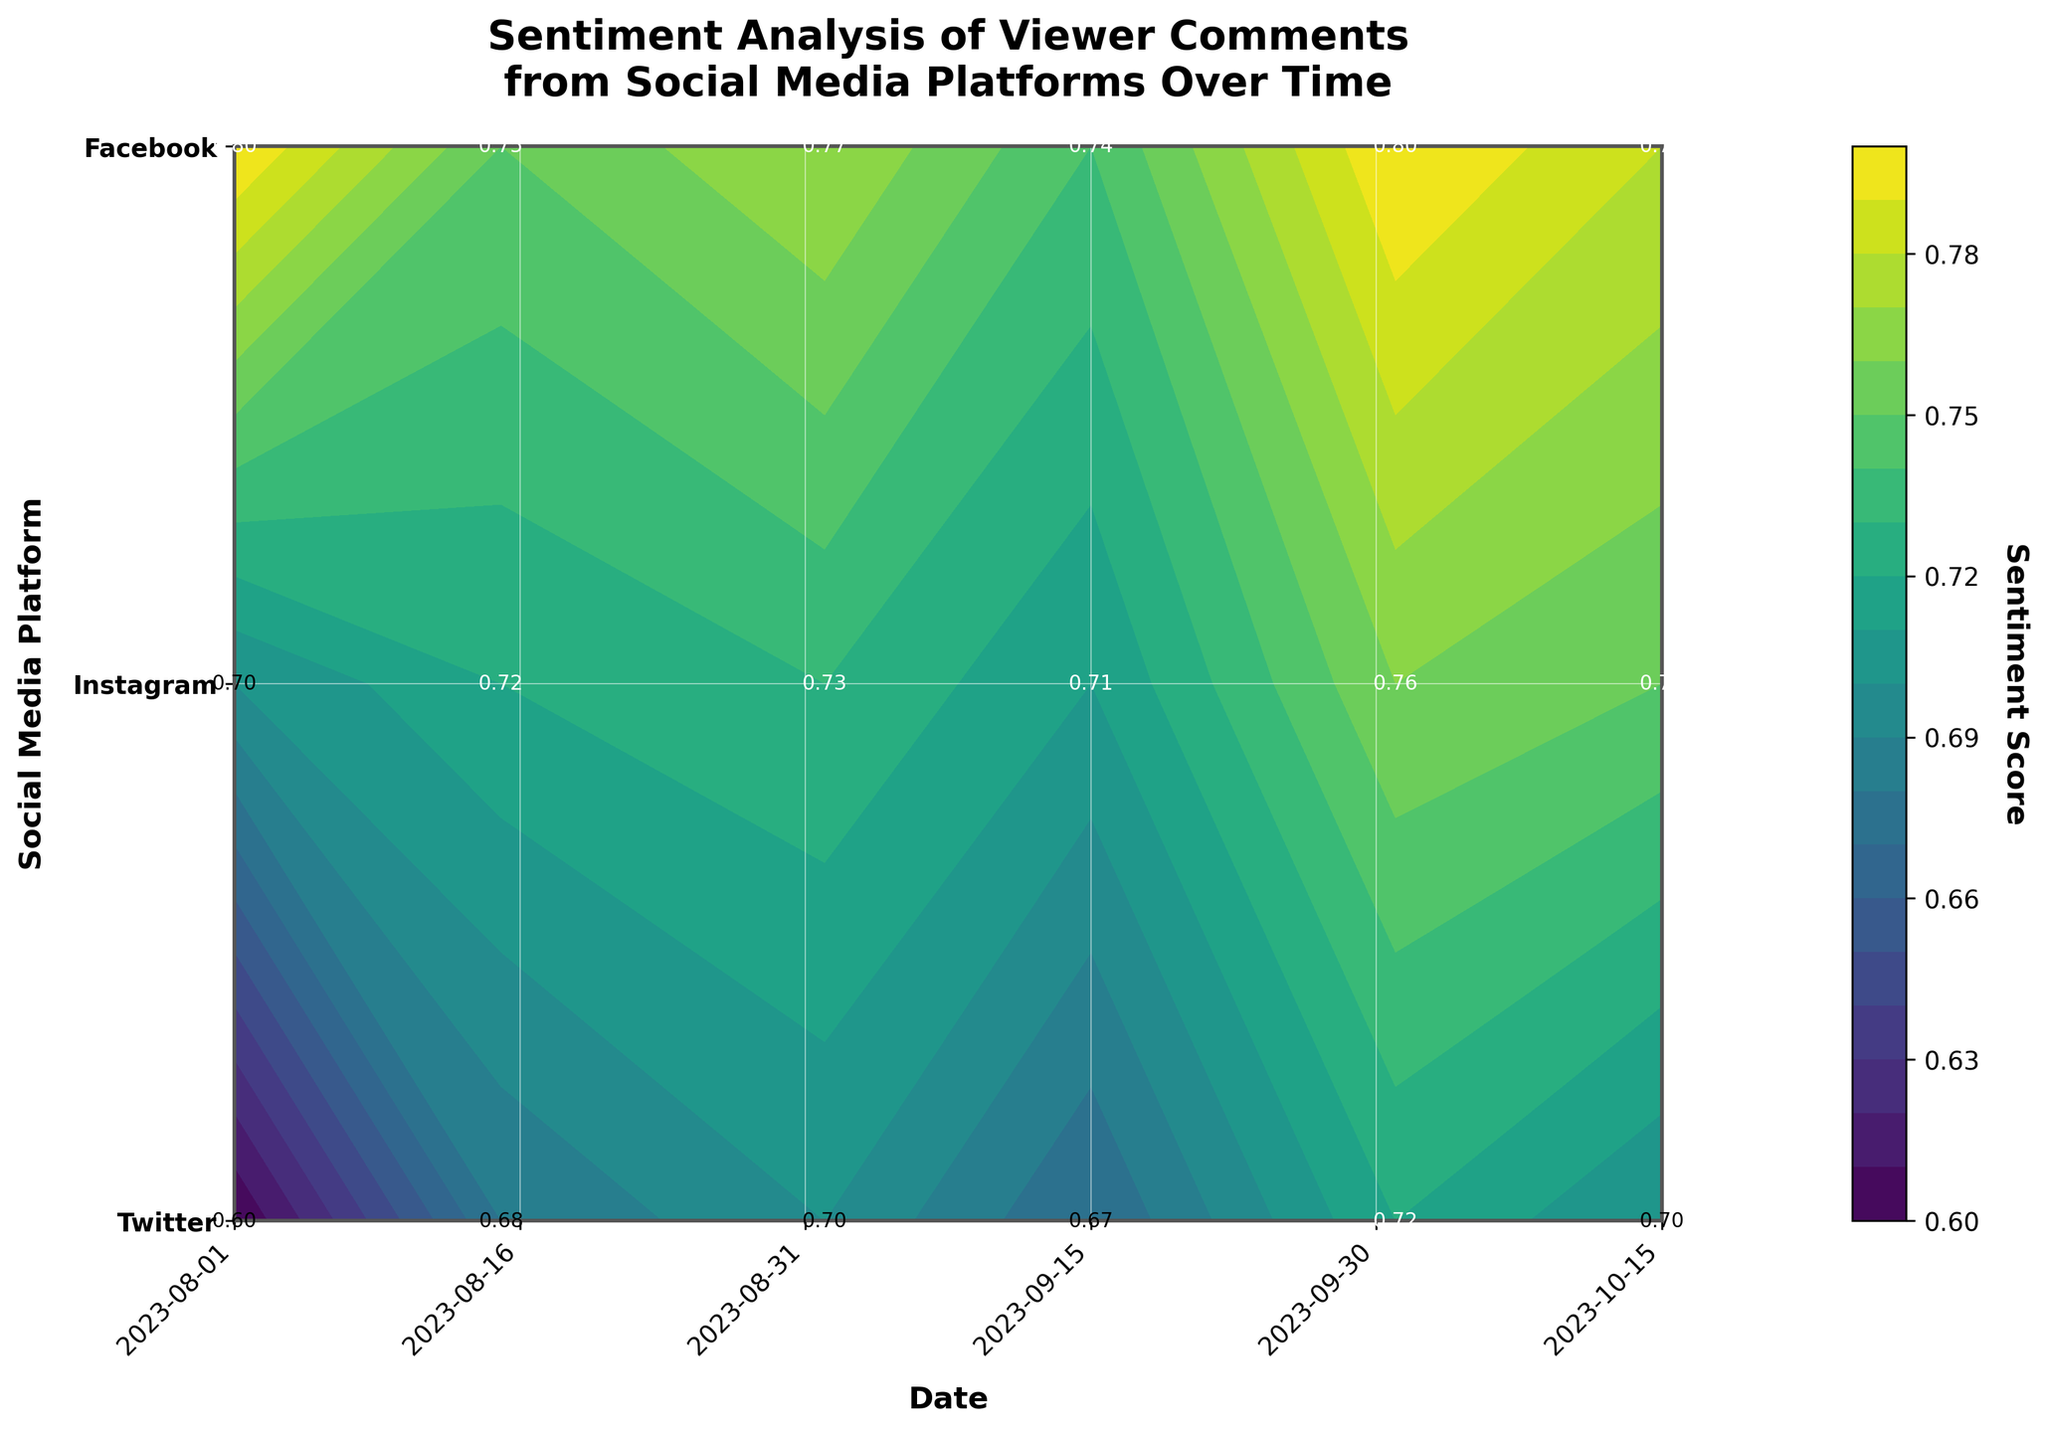What is the title of the figure? The title is usually positioned at the top of the plot. Here, it states, "Sentiment Analysis of Viewer Comments from Social Media Platforms Over Time."
Answer: Sentiment Analysis of Viewer Comments from Social Media Platforms Over Time Which axis represents the social media platforms? The y-axis is labeled with the social media platforms, as we can see Twitter, Instagram, and Facebook listed vertically on this axis.
Answer: y-axis How many unique timestamps are plotted on the x-axis? The x-axis labels represent the dates, ranging from 2023-08-01 to 2023-10-15. By counting, there are six unique dates.
Answer: 6 Which social media platform has the highest sentiment score on 2023-10-01? By looking at the labeled sentiment scores on the contour plot for the date 2023-10-01, we can see that Twitter has the highest value of 0.8.
Answer: Twitter How does the sentiment score for Facebook change from 2023-08-01 to 2023-10-15? We need to compare the sentiment scores of Facebook on these two dates, which are 0.6 on 2023-08-01 and 0.7 on 2023-10-15, showing an increase.
Answer: It increases from 0.6 to 0.7 What is the average sentiment score for Instagram across all dates? The sentiment scores for Instagram across six dates are 0.7, 0.72, 0.73, 0.71, 0.76, and 0.75. Summing these gives 4.37, and dividing by the six data points results in 0.7283.
Answer: 0.7283 Which date shows the lowest overall sentiment score for Facebook? By studying the labeled sentiment scores for Facebook across all dates, we find the lowest score of 0.6 on 2023-08-01.
Answer: 2023-08-01 On average, which platform has the highest sentiment score across all dates? We calculate the average sentiment scores for each platform. Twitter: (0.8 + 0.75 + 0.77 + 0.74 + 0.8 + 0.78)/6 = 0.7733; Instagram: 0.7283 (calculated earlier); Facebook: (0.6 + 0.68 + 0.7 + 0.67 + 0.72 + 0.7)/6 = 0.6783. Thus, Twitter has the highest average score.
Answer: Twitter Compare the sentiment score for Twitter and Instagram on 2023-08-15. Which one is higher? Referring to the date 2023-08-15, Twitter's sentiment score is 0.75, and Instagram's is 0.72. Therefore, Twitter's score is higher.
Answer: Twitter How does the sentiment change for Twitter between the first and last timestamps? We compare Twitter's sentiment scores on 2023-08-01 (0.8) and 2023-10-15 (0.78), noting that it slightly decreases by 0.02.
Answer: It decreases by 0.02 